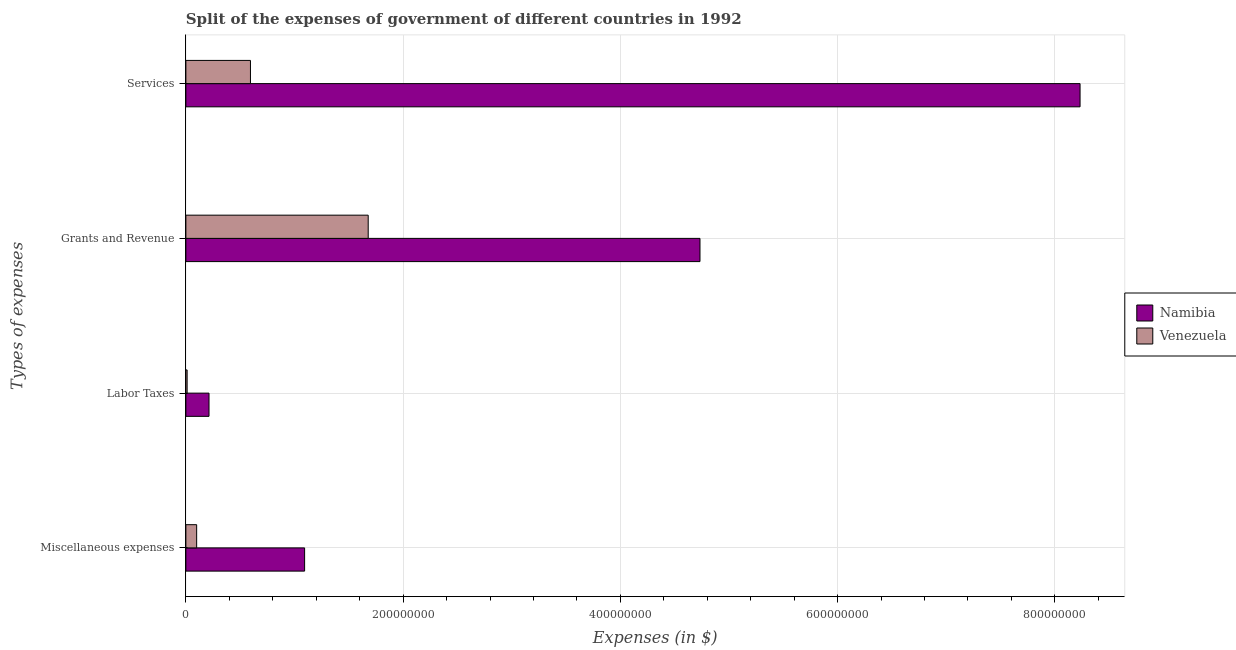How many groups of bars are there?
Your response must be concise. 4. What is the label of the 1st group of bars from the top?
Give a very brief answer. Services. What is the amount spent on miscellaneous expenses in Namibia?
Provide a short and direct response. 1.09e+08. Across all countries, what is the maximum amount spent on services?
Your response must be concise. 8.23e+08. Across all countries, what is the minimum amount spent on services?
Offer a very short reply. 5.95e+07. In which country was the amount spent on miscellaneous expenses maximum?
Your answer should be compact. Namibia. In which country was the amount spent on labor taxes minimum?
Make the answer very short. Venezuela. What is the total amount spent on grants and revenue in the graph?
Make the answer very short. 6.41e+08. What is the difference between the amount spent on labor taxes in Namibia and that in Venezuela?
Offer a very short reply. 2.01e+07. What is the difference between the amount spent on labor taxes in Venezuela and the amount spent on grants and revenue in Namibia?
Your answer should be very brief. -4.72e+08. What is the average amount spent on miscellaneous expenses per country?
Your answer should be compact. 5.96e+07. What is the difference between the amount spent on labor taxes and amount spent on services in Namibia?
Keep it short and to the point. -8.02e+08. In how many countries, is the amount spent on grants and revenue greater than 120000000 $?
Provide a short and direct response. 2. What is the ratio of the amount spent on grants and revenue in Namibia to that in Venezuela?
Keep it short and to the point. 2.82. What is the difference between the highest and the second highest amount spent on grants and revenue?
Your answer should be compact. 3.05e+08. What is the difference between the highest and the lowest amount spent on miscellaneous expenses?
Give a very brief answer. 9.94e+07. Is the sum of the amount spent on miscellaneous expenses in Venezuela and Namibia greater than the maximum amount spent on labor taxes across all countries?
Provide a short and direct response. Yes. What does the 2nd bar from the top in Grants and Revenue represents?
Ensure brevity in your answer.  Namibia. What does the 1st bar from the bottom in Miscellaneous expenses represents?
Offer a terse response. Namibia. How many countries are there in the graph?
Provide a short and direct response. 2. Are the values on the major ticks of X-axis written in scientific E-notation?
Offer a terse response. No. Does the graph contain any zero values?
Keep it short and to the point. No. Where does the legend appear in the graph?
Ensure brevity in your answer.  Center right. How many legend labels are there?
Provide a short and direct response. 2. How are the legend labels stacked?
Offer a terse response. Vertical. What is the title of the graph?
Ensure brevity in your answer.  Split of the expenses of government of different countries in 1992. What is the label or title of the X-axis?
Your answer should be compact. Expenses (in $). What is the label or title of the Y-axis?
Ensure brevity in your answer.  Types of expenses. What is the Expenses (in $) in Namibia in Miscellaneous expenses?
Offer a very short reply. 1.09e+08. What is the Expenses (in $) in Venezuela in Miscellaneous expenses?
Give a very brief answer. 9.93e+06. What is the Expenses (in $) in Namibia in Labor Taxes?
Your response must be concise. 2.13e+07. What is the Expenses (in $) in Venezuela in Labor Taxes?
Give a very brief answer. 1.15e+06. What is the Expenses (in $) of Namibia in Grants and Revenue?
Your answer should be very brief. 4.73e+08. What is the Expenses (in $) of Venezuela in Grants and Revenue?
Offer a terse response. 1.68e+08. What is the Expenses (in $) in Namibia in Services?
Provide a succinct answer. 8.23e+08. What is the Expenses (in $) of Venezuela in Services?
Your answer should be compact. 5.95e+07. Across all Types of expenses, what is the maximum Expenses (in $) in Namibia?
Offer a very short reply. 8.23e+08. Across all Types of expenses, what is the maximum Expenses (in $) in Venezuela?
Your answer should be very brief. 1.68e+08. Across all Types of expenses, what is the minimum Expenses (in $) of Namibia?
Your answer should be very brief. 2.13e+07. Across all Types of expenses, what is the minimum Expenses (in $) of Venezuela?
Offer a terse response. 1.15e+06. What is the total Expenses (in $) of Namibia in the graph?
Provide a short and direct response. 1.43e+09. What is the total Expenses (in $) of Venezuela in the graph?
Give a very brief answer. 2.38e+08. What is the difference between the Expenses (in $) in Namibia in Miscellaneous expenses and that in Labor Taxes?
Offer a terse response. 8.80e+07. What is the difference between the Expenses (in $) of Venezuela in Miscellaneous expenses and that in Labor Taxes?
Provide a succinct answer. 8.78e+06. What is the difference between the Expenses (in $) in Namibia in Miscellaneous expenses and that in Grants and Revenue?
Offer a very short reply. -3.64e+08. What is the difference between the Expenses (in $) in Venezuela in Miscellaneous expenses and that in Grants and Revenue?
Your answer should be very brief. -1.58e+08. What is the difference between the Expenses (in $) of Namibia in Miscellaneous expenses and that in Services?
Your response must be concise. -7.14e+08. What is the difference between the Expenses (in $) of Venezuela in Miscellaneous expenses and that in Services?
Provide a succinct answer. -4.95e+07. What is the difference between the Expenses (in $) of Namibia in Labor Taxes and that in Grants and Revenue?
Keep it short and to the point. -4.52e+08. What is the difference between the Expenses (in $) in Venezuela in Labor Taxes and that in Grants and Revenue?
Your response must be concise. -1.67e+08. What is the difference between the Expenses (in $) of Namibia in Labor Taxes and that in Services?
Your answer should be compact. -8.02e+08. What is the difference between the Expenses (in $) of Venezuela in Labor Taxes and that in Services?
Provide a short and direct response. -5.83e+07. What is the difference between the Expenses (in $) of Namibia in Grants and Revenue and that in Services?
Your response must be concise. -3.50e+08. What is the difference between the Expenses (in $) in Venezuela in Grants and Revenue and that in Services?
Offer a terse response. 1.08e+08. What is the difference between the Expenses (in $) of Namibia in Miscellaneous expenses and the Expenses (in $) of Venezuela in Labor Taxes?
Offer a terse response. 1.08e+08. What is the difference between the Expenses (in $) in Namibia in Miscellaneous expenses and the Expenses (in $) in Venezuela in Grants and Revenue?
Provide a succinct answer. -5.86e+07. What is the difference between the Expenses (in $) of Namibia in Miscellaneous expenses and the Expenses (in $) of Venezuela in Services?
Keep it short and to the point. 4.98e+07. What is the difference between the Expenses (in $) in Namibia in Labor Taxes and the Expenses (in $) in Venezuela in Grants and Revenue?
Your answer should be compact. -1.47e+08. What is the difference between the Expenses (in $) of Namibia in Labor Taxes and the Expenses (in $) of Venezuela in Services?
Your response must be concise. -3.82e+07. What is the difference between the Expenses (in $) of Namibia in Grants and Revenue and the Expenses (in $) of Venezuela in Services?
Make the answer very short. 4.14e+08. What is the average Expenses (in $) of Namibia per Types of expenses?
Provide a succinct answer. 3.57e+08. What is the average Expenses (in $) in Venezuela per Types of expenses?
Your response must be concise. 5.96e+07. What is the difference between the Expenses (in $) of Namibia and Expenses (in $) of Venezuela in Miscellaneous expenses?
Offer a terse response. 9.94e+07. What is the difference between the Expenses (in $) of Namibia and Expenses (in $) of Venezuela in Labor Taxes?
Ensure brevity in your answer.  2.01e+07. What is the difference between the Expenses (in $) in Namibia and Expenses (in $) in Venezuela in Grants and Revenue?
Provide a short and direct response. 3.05e+08. What is the difference between the Expenses (in $) of Namibia and Expenses (in $) of Venezuela in Services?
Offer a very short reply. 7.64e+08. What is the ratio of the Expenses (in $) of Namibia in Miscellaneous expenses to that in Labor Taxes?
Ensure brevity in your answer.  5.13. What is the ratio of the Expenses (in $) in Venezuela in Miscellaneous expenses to that in Labor Taxes?
Give a very brief answer. 8.62. What is the ratio of the Expenses (in $) in Namibia in Miscellaneous expenses to that in Grants and Revenue?
Give a very brief answer. 0.23. What is the ratio of the Expenses (in $) in Venezuela in Miscellaneous expenses to that in Grants and Revenue?
Offer a terse response. 0.06. What is the ratio of the Expenses (in $) of Namibia in Miscellaneous expenses to that in Services?
Provide a short and direct response. 0.13. What is the ratio of the Expenses (in $) in Venezuela in Miscellaneous expenses to that in Services?
Your answer should be compact. 0.17. What is the ratio of the Expenses (in $) in Namibia in Labor Taxes to that in Grants and Revenue?
Make the answer very short. 0.04. What is the ratio of the Expenses (in $) in Venezuela in Labor Taxes to that in Grants and Revenue?
Your answer should be compact. 0.01. What is the ratio of the Expenses (in $) of Namibia in Labor Taxes to that in Services?
Your answer should be compact. 0.03. What is the ratio of the Expenses (in $) in Venezuela in Labor Taxes to that in Services?
Provide a short and direct response. 0.02. What is the ratio of the Expenses (in $) of Namibia in Grants and Revenue to that in Services?
Your answer should be compact. 0.57. What is the ratio of the Expenses (in $) of Venezuela in Grants and Revenue to that in Services?
Give a very brief answer. 2.82. What is the difference between the highest and the second highest Expenses (in $) in Namibia?
Keep it short and to the point. 3.50e+08. What is the difference between the highest and the second highest Expenses (in $) in Venezuela?
Offer a terse response. 1.08e+08. What is the difference between the highest and the lowest Expenses (in $) in Namibia?
Give a very brief answer. 8.02e+08. What is the difference between the highest and the lowest Expenses (in $) of Venezuela?
Offer a very short reply. 1.67e+08. 